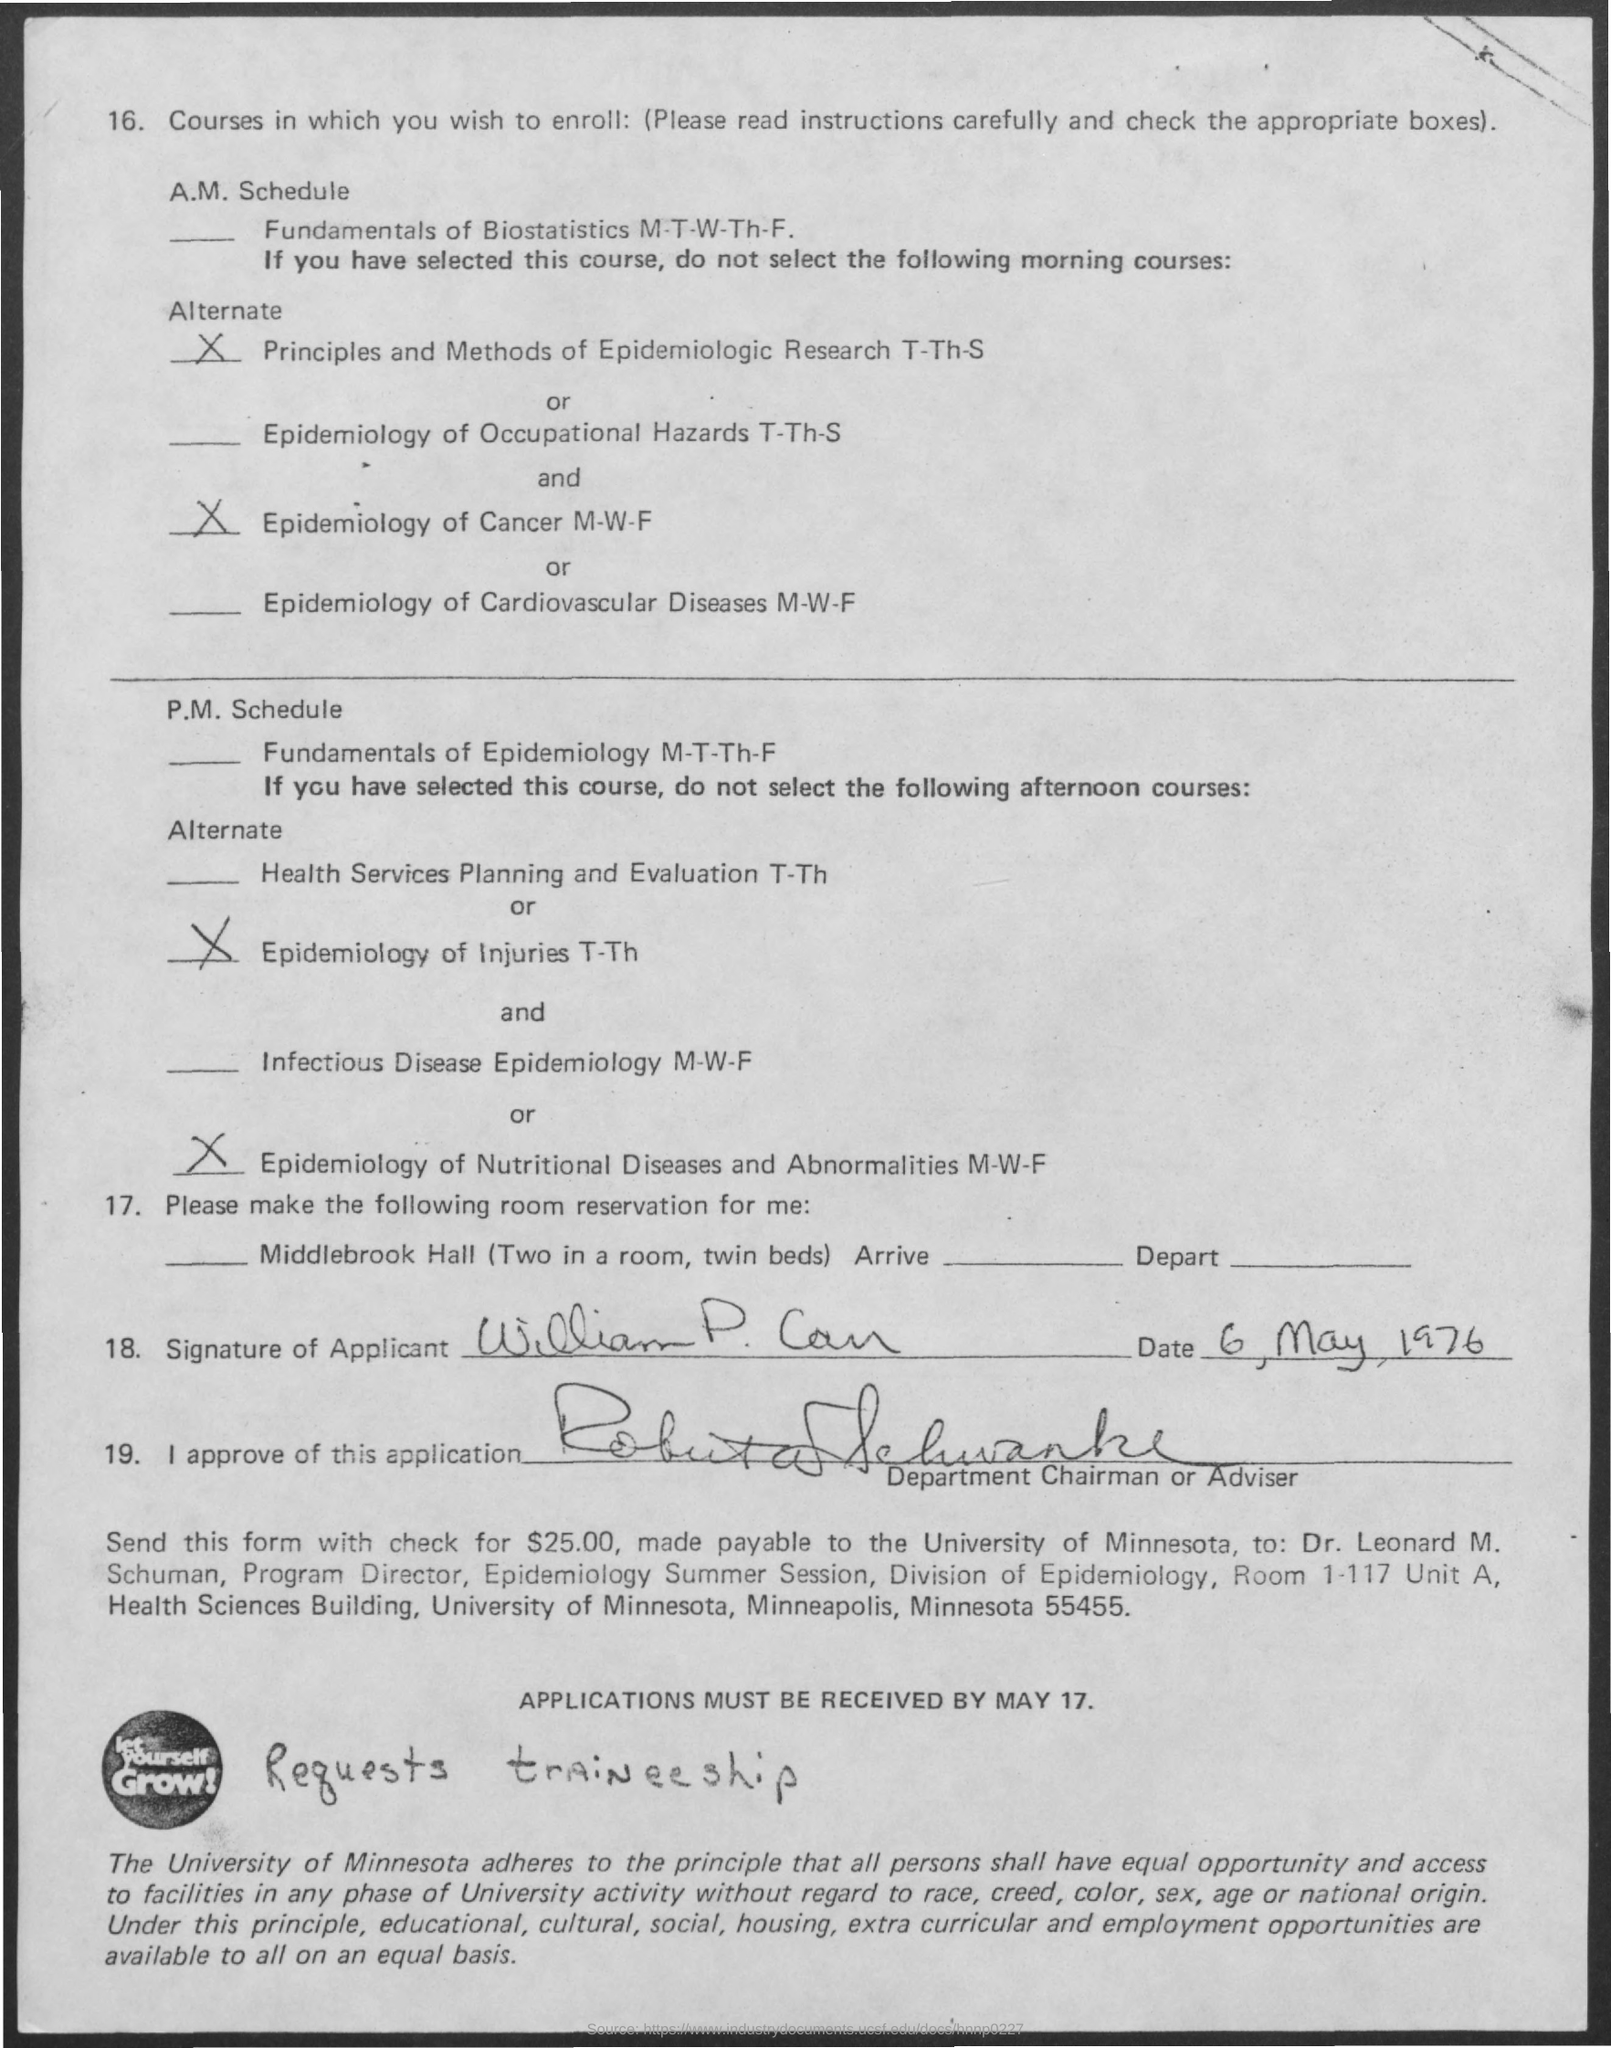When is the Epidemiology of Cancer Course ?
Offer a very short reply. M-W-F. By When the Applications must be Received ?
Offer a very short reply. MAY 17. 